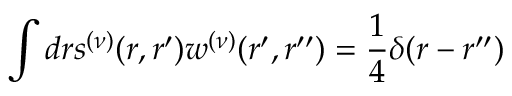Convert formula to latex. <formula><loc_0><loc_0><loc_500><loc_500>\int d r s ^ { ( \nu ) } ( r , r ^ { \prime } ) w ^ { ( \nu ) } ( r ^ { \prime } , r ^ { \prime \prime } ) = \frac { 1 } { 4 } \delta ( r - r ^ { \prime \prime } )</formula> 